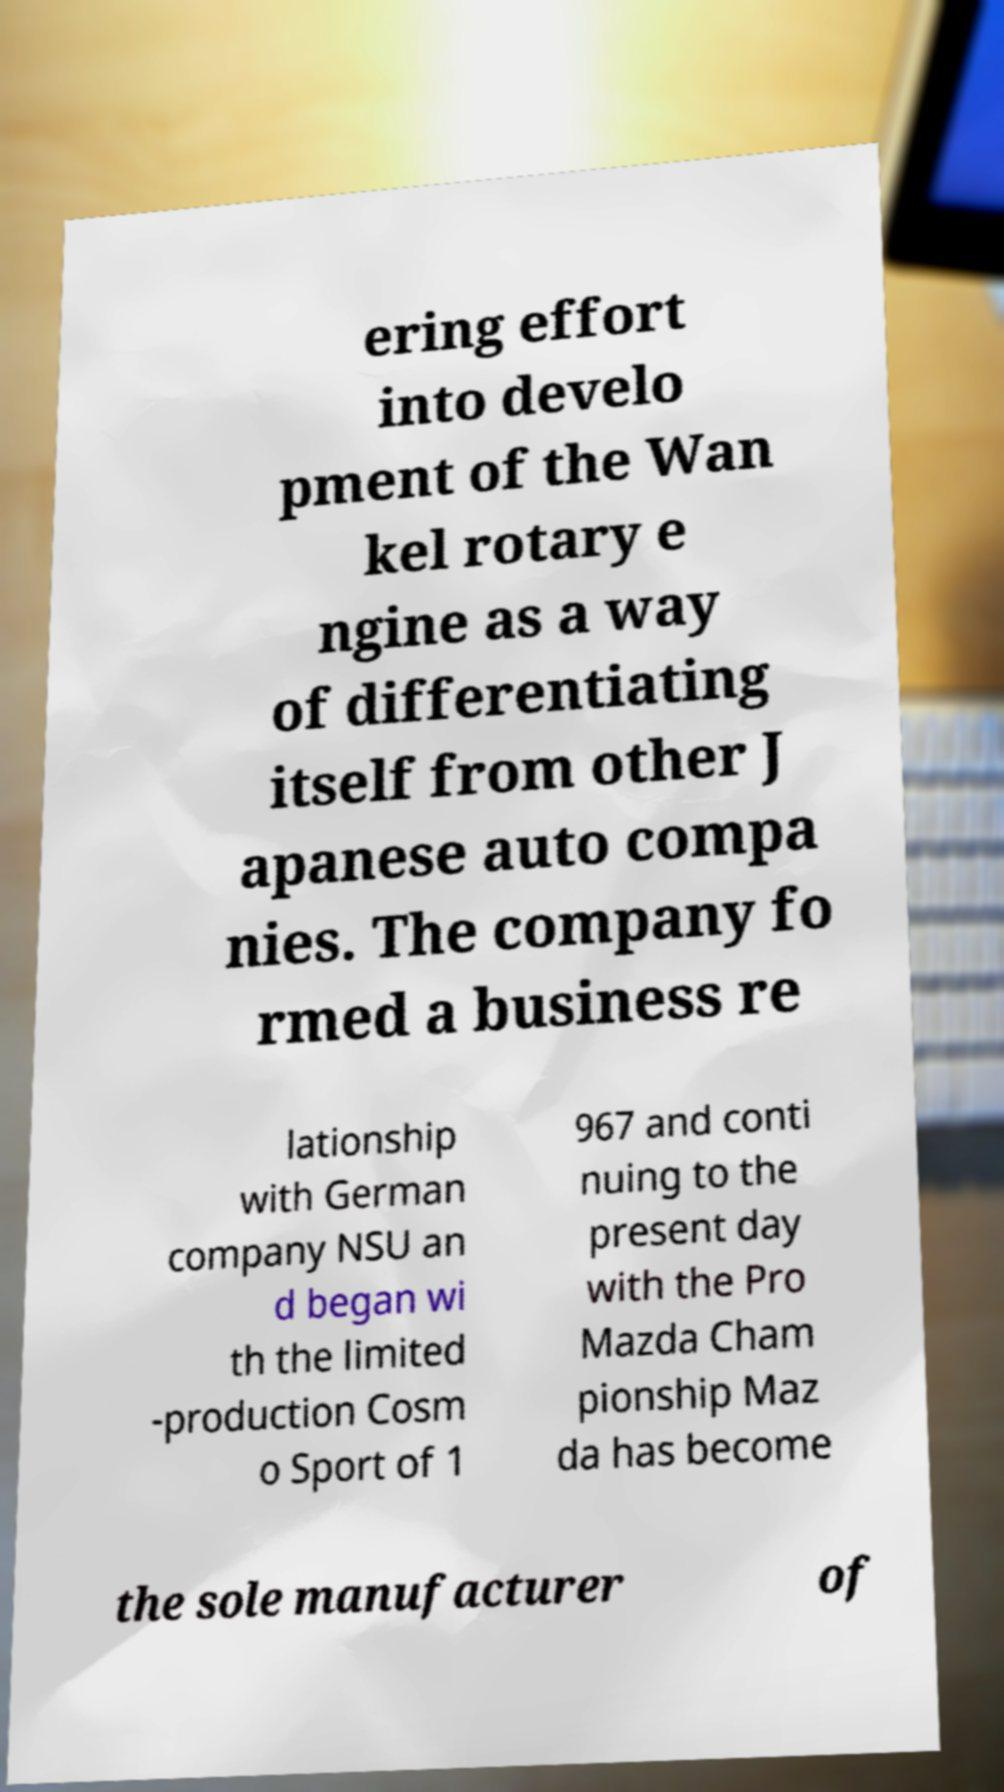For documentation purposes, I need the text within this image transcribed. Could you provide that? ering effort into develo pment of the Wan kel rotary e ngine as a way of differentiating itself from other J apanese auto compa nies. The company fo rmed a business re lationship with German company NSU an d began wi th the limited -production Cosm o Sport of 1 967 and conti nuing to the present day with the Pro Mazda Cham pionship Maz da has become the sole manufacturer of 